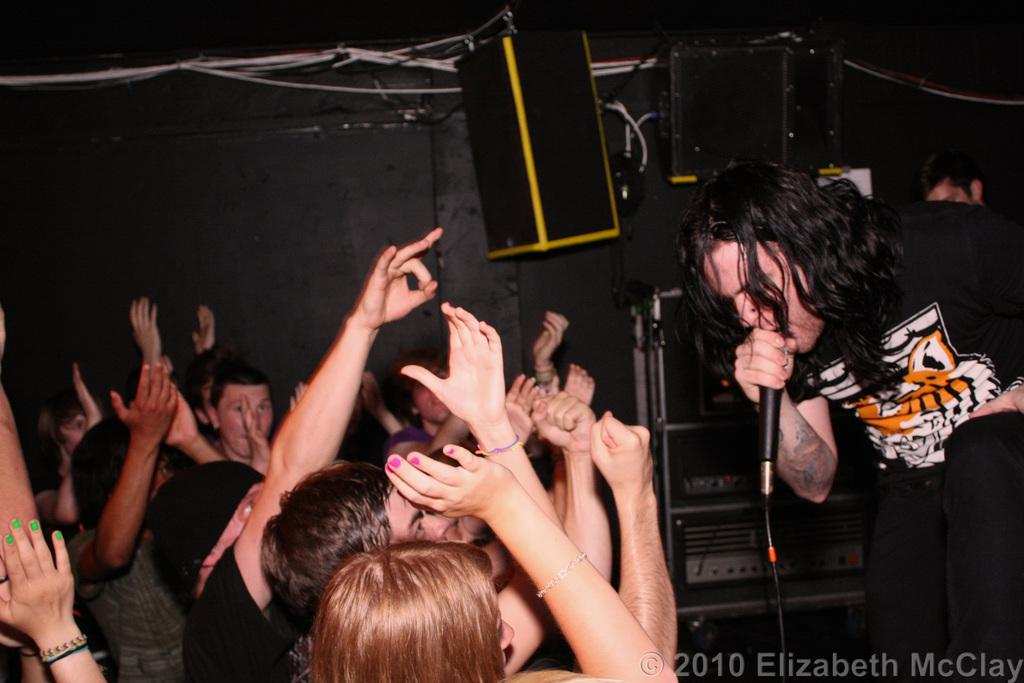What is the person in the image doing? The person is playing music. What object is the person holding in the image? The person is holding a microphone. What color is the shirt the person is wearing? The person is wearing a black shirt. Who is the person playing music for? There are audience members on the left side of the image who are listening to the music. What type of toy is the person playing with in the image? There is no toy present in the image; the person is playing music with a microphone. 